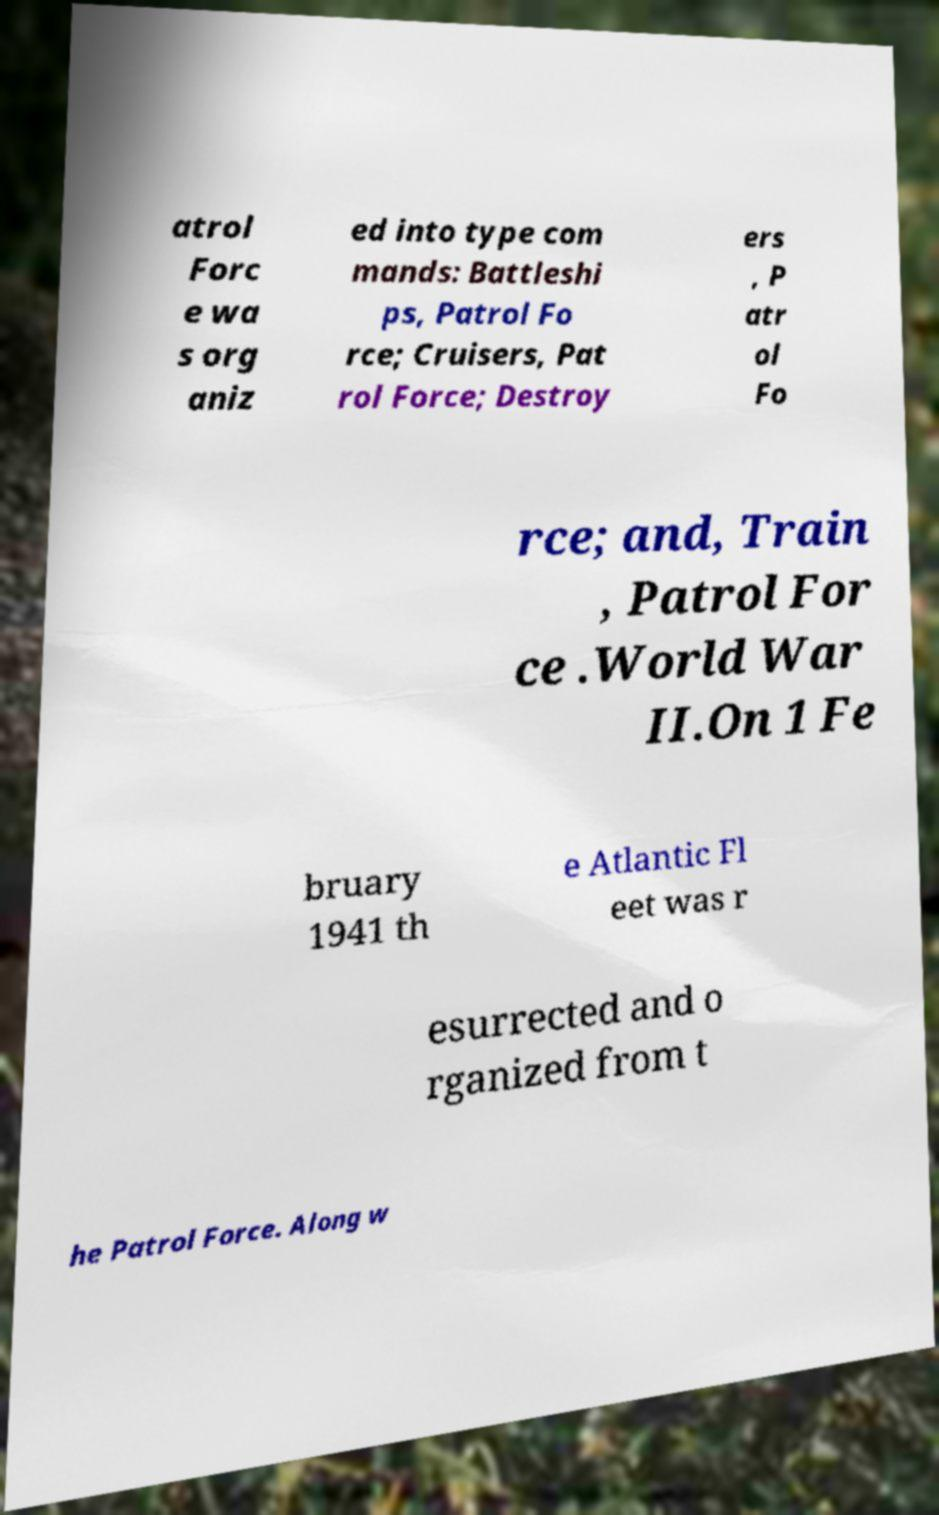I need the written content from this picture converted into text. Can you do that? atrol Forc e wa s org aniz ed into type com mands: Battleshi ps, Patrol Fo rce; Cruisers, Pat rol Force; Destroy ers , P atr ol Fo rce; and, Train , Patrol For ce .World War II.On 1 Fe bruary 1941 th e Atlantic Fl eet was r esurrected and o rganized from t he Patrol Force. Along w 